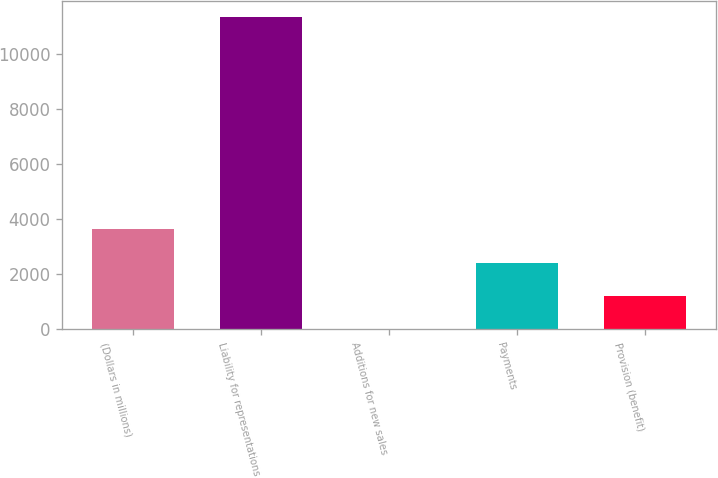Convert chart. <chart><loc_0><loc_0><loc_500><loc_500><bar_chart><fcel>(Dollars in millions)<fcel>Liability for representations<fcel>Additions for new sales<fcel>Payments<fcel>Provision (benefit)<nl><fcel>3628.5<fcel>11326<fcel>6<fcel>2421<fcel>1213.5<nl></chart> 